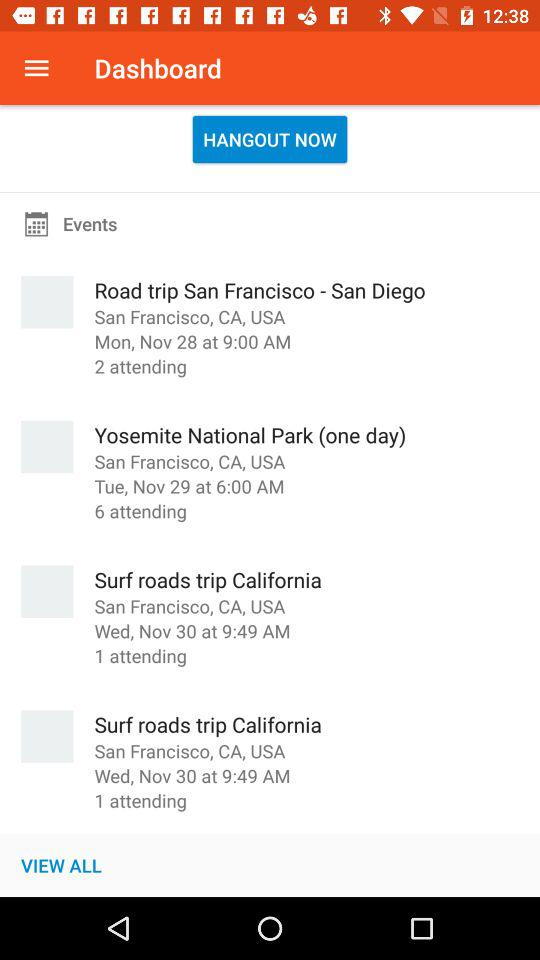What is the date and time of "Surf roads trip California" event? The date is Wednesday, November 30, and the time is 9:49 AM. 